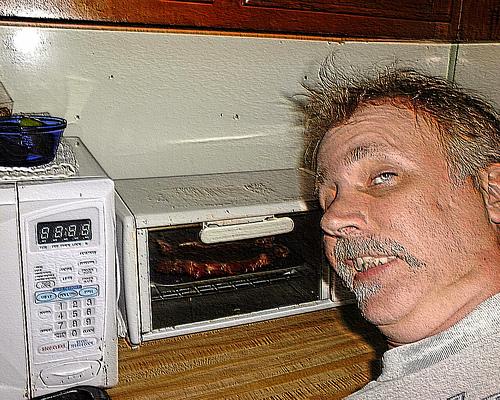What is end the oven?
Keep it brief. Food. Is there a microwave?
Be succinct. Yes. Does the man have good teeth?
Short answer required. No. 